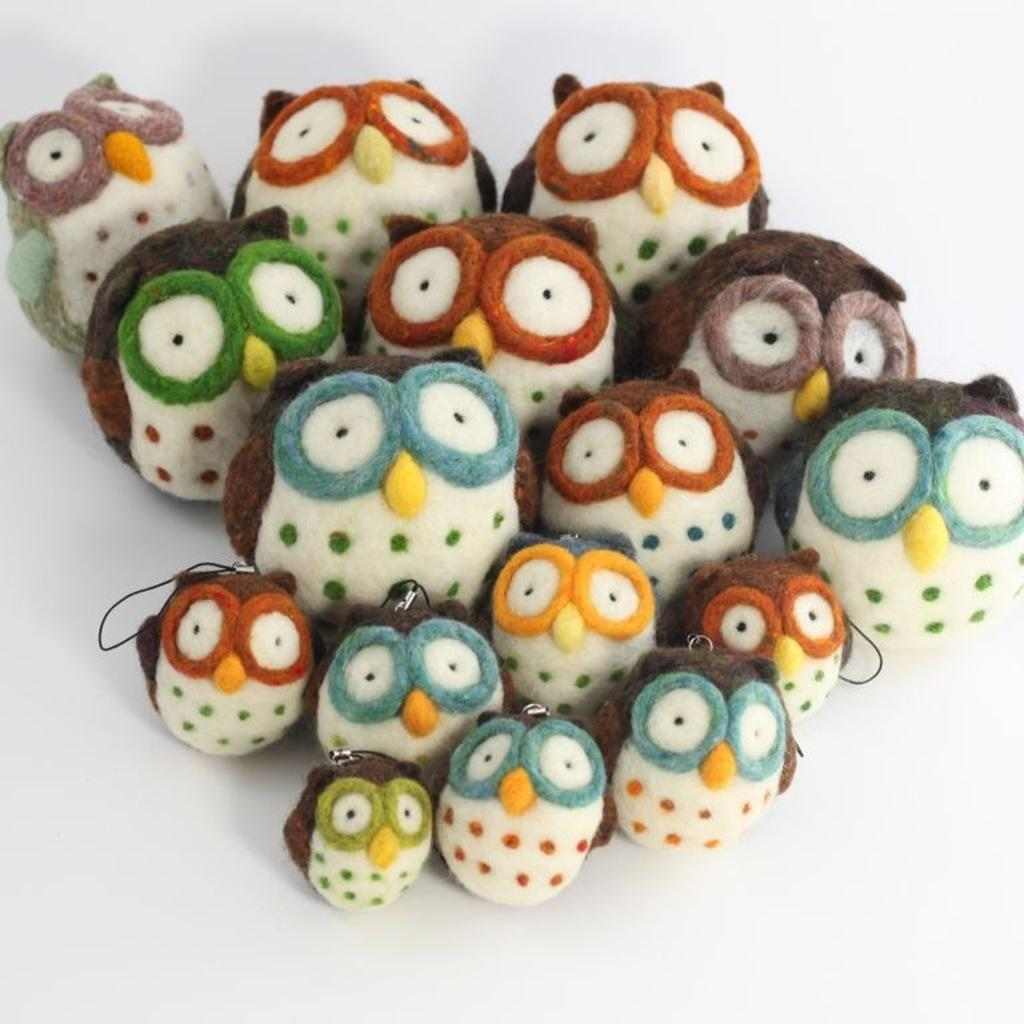What type of toys are present in the image? There are owl toys in the image. What is the color of the surface on which the toys are placed? The owl toys are on a white surface. What color of paint is being used to create the owl toys in the image? There is no indication in the image that the owl toys are being painted or created, and therefore no paint color can be determined. 